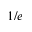<formula> <loc_0><loc_0><loc_500><loc_500>1 / e</formula> 